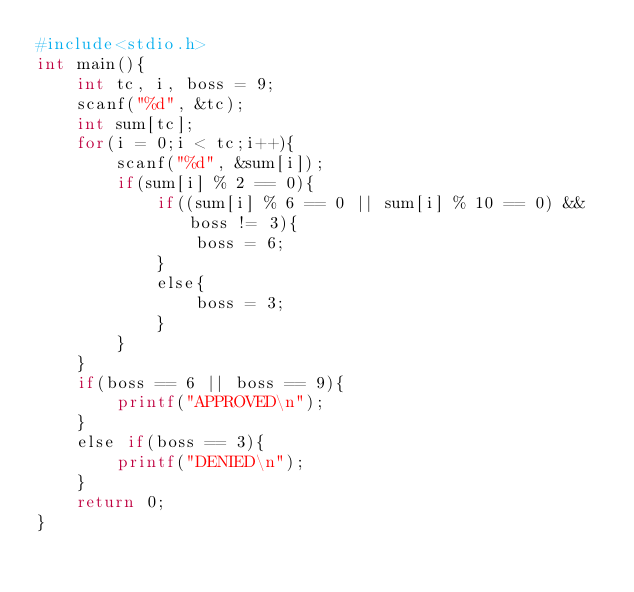<code> <loc_0><loc_0><loc_500><loc_500><_Awk_>#include<stdio.h>
int main(){
    int tc, i, boss = 9;
    scanf("%d", &tc);
    int sum[tc];
    for(i = 0;i < tc;i++){
        scanf("%d", &sum[i]);
        if(sum[i] % 2 == 0){
            if((sum[i] % 6 == 0 || sum[i] % 10 == 0) && boss != 3){
                boss = 6;
            }
            else{
                boss = 3;
            }
        }
    }
    if(boss == 6 || boss == 9){
        printf("APPROVED\n");
    }
    else if(boss == 3){
        printf("DENIED\n");
    }
    return 0;
}</code> 